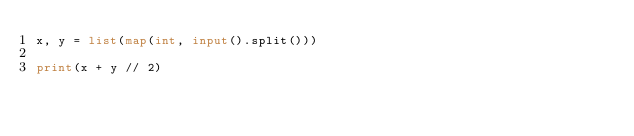Convert code to text. <code><loc_0><loc_0><loc_500><loc_500><_Python_>x, y = list(map(int, input().split()))

print(x + y // 2)</code> 